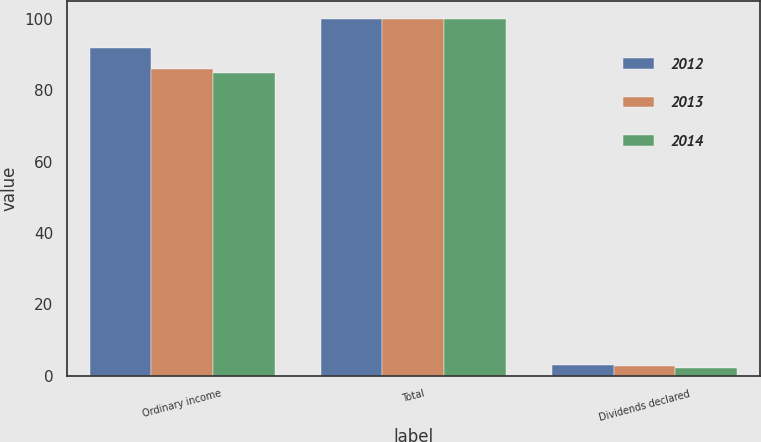<chart> <loc_0><loc_0><loc_500><loc_500><stacked_bar_chart><ecel><fcel>Ordinary income<fcel>Total<fcel>Dividends declared<nl><fcel>2012<fcel>91.8<fcel>100<fcel>2.88<nl><fcel>2013<fcel>85.9<fcel>100<fcel>2.61<nl><fcel>2014<fcel>85<fcel>100<fcel>2.09<nl></chart> 